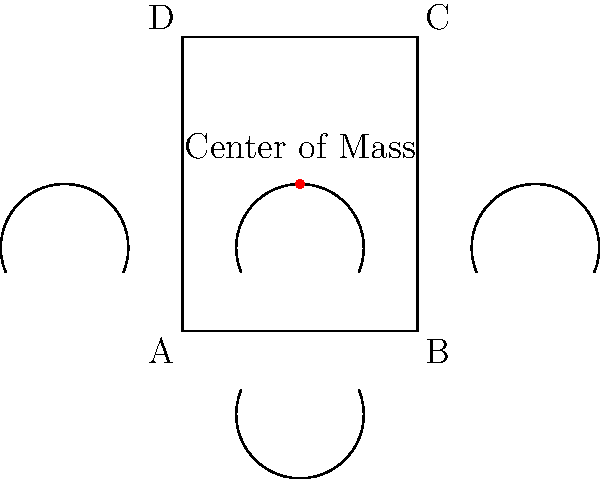An ornate wrought iron gate for a Victorian-era mansion has a rectangular frame measuring 2 meters wide and 2.5 meters tall. The intricate design is symmetrical both vertically and horizontally. If the gate's center of mass is located exactly at its geometric center, what fraction of the gate's total mass is contained in the upper half of the gate? To solve this problem, we'll follow these steps:

1) First, let's understand what the center of mass being at the geometric center means:
   - The gate is symmetrical both vertically and horizontally.
   - The mass distribution is uniform across the gate.

2) The geometric center of a rectangle is at the intersection of its diagonals, which is exactly halfway between the top and bottom of the gate.

3) Since the center of mass coincides with the geometric center, we can conclude that the mass is evenly distributed between the upper and lower halves of the gate.

4) To express this mathematically:
   Let $M$ be the total mass of the gate.
   Let $M_u$ be the mass of the upper half.
   Let $M_l$ be the mass of the lower half.

   We know that $M = M_u + M_l$ and $M_u = M_l$

5) Therefore, $M_u = M_l = \frac{1}{2}M$

6) The question asks for the fraction of the total mass in the upper half:

   $\frac{M_u}{M} = \frac{\frac{1}{2}M}{M} = \frac{1}{2}$

Thus, the upper half contains exactly half of the gate's total mass.
Answer: $\frac{1}{2}$ 